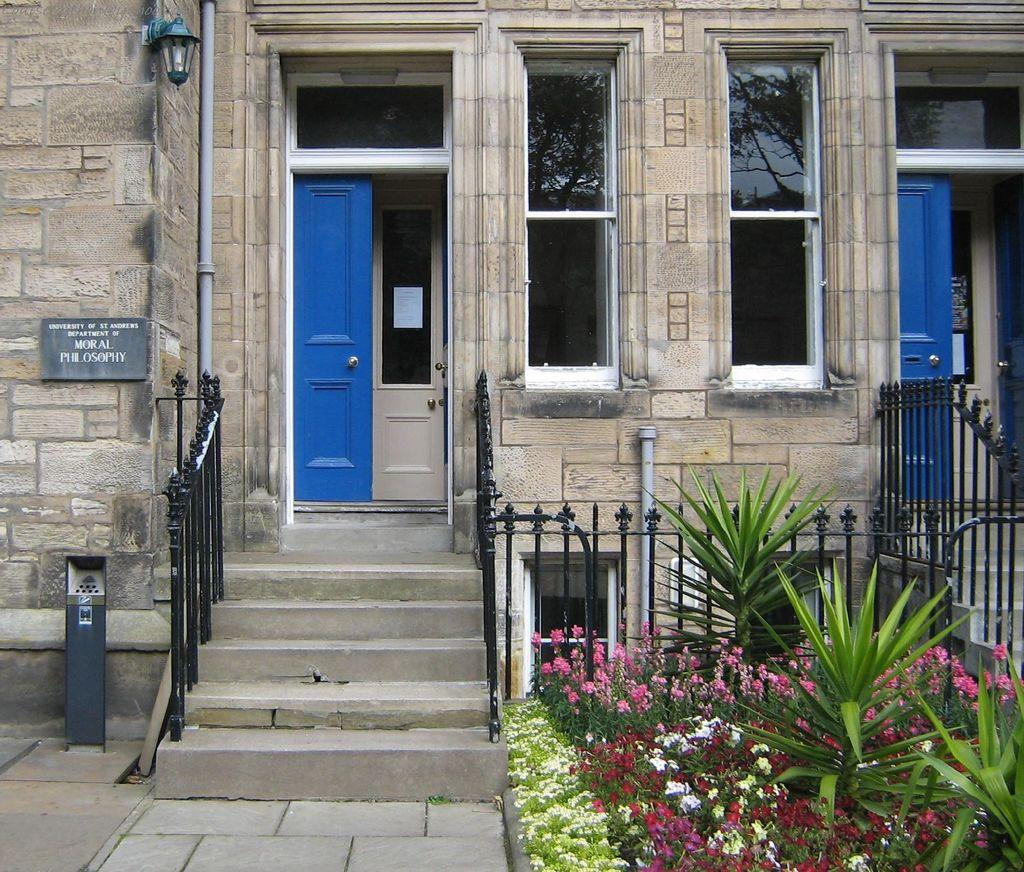What type of structure is visible in the image? There is a house in the image. What is a feature of the house that can be seen? The house has a door. What other object is present in the image? There is a board in the image. What type of barrier can be seen in the image? There is fencing in the image. What type of living organisms are present in the image? There are plants in the image. What type of mask is hanging on the door of the house in the image? There is no mask present on the door of the house in the image. 